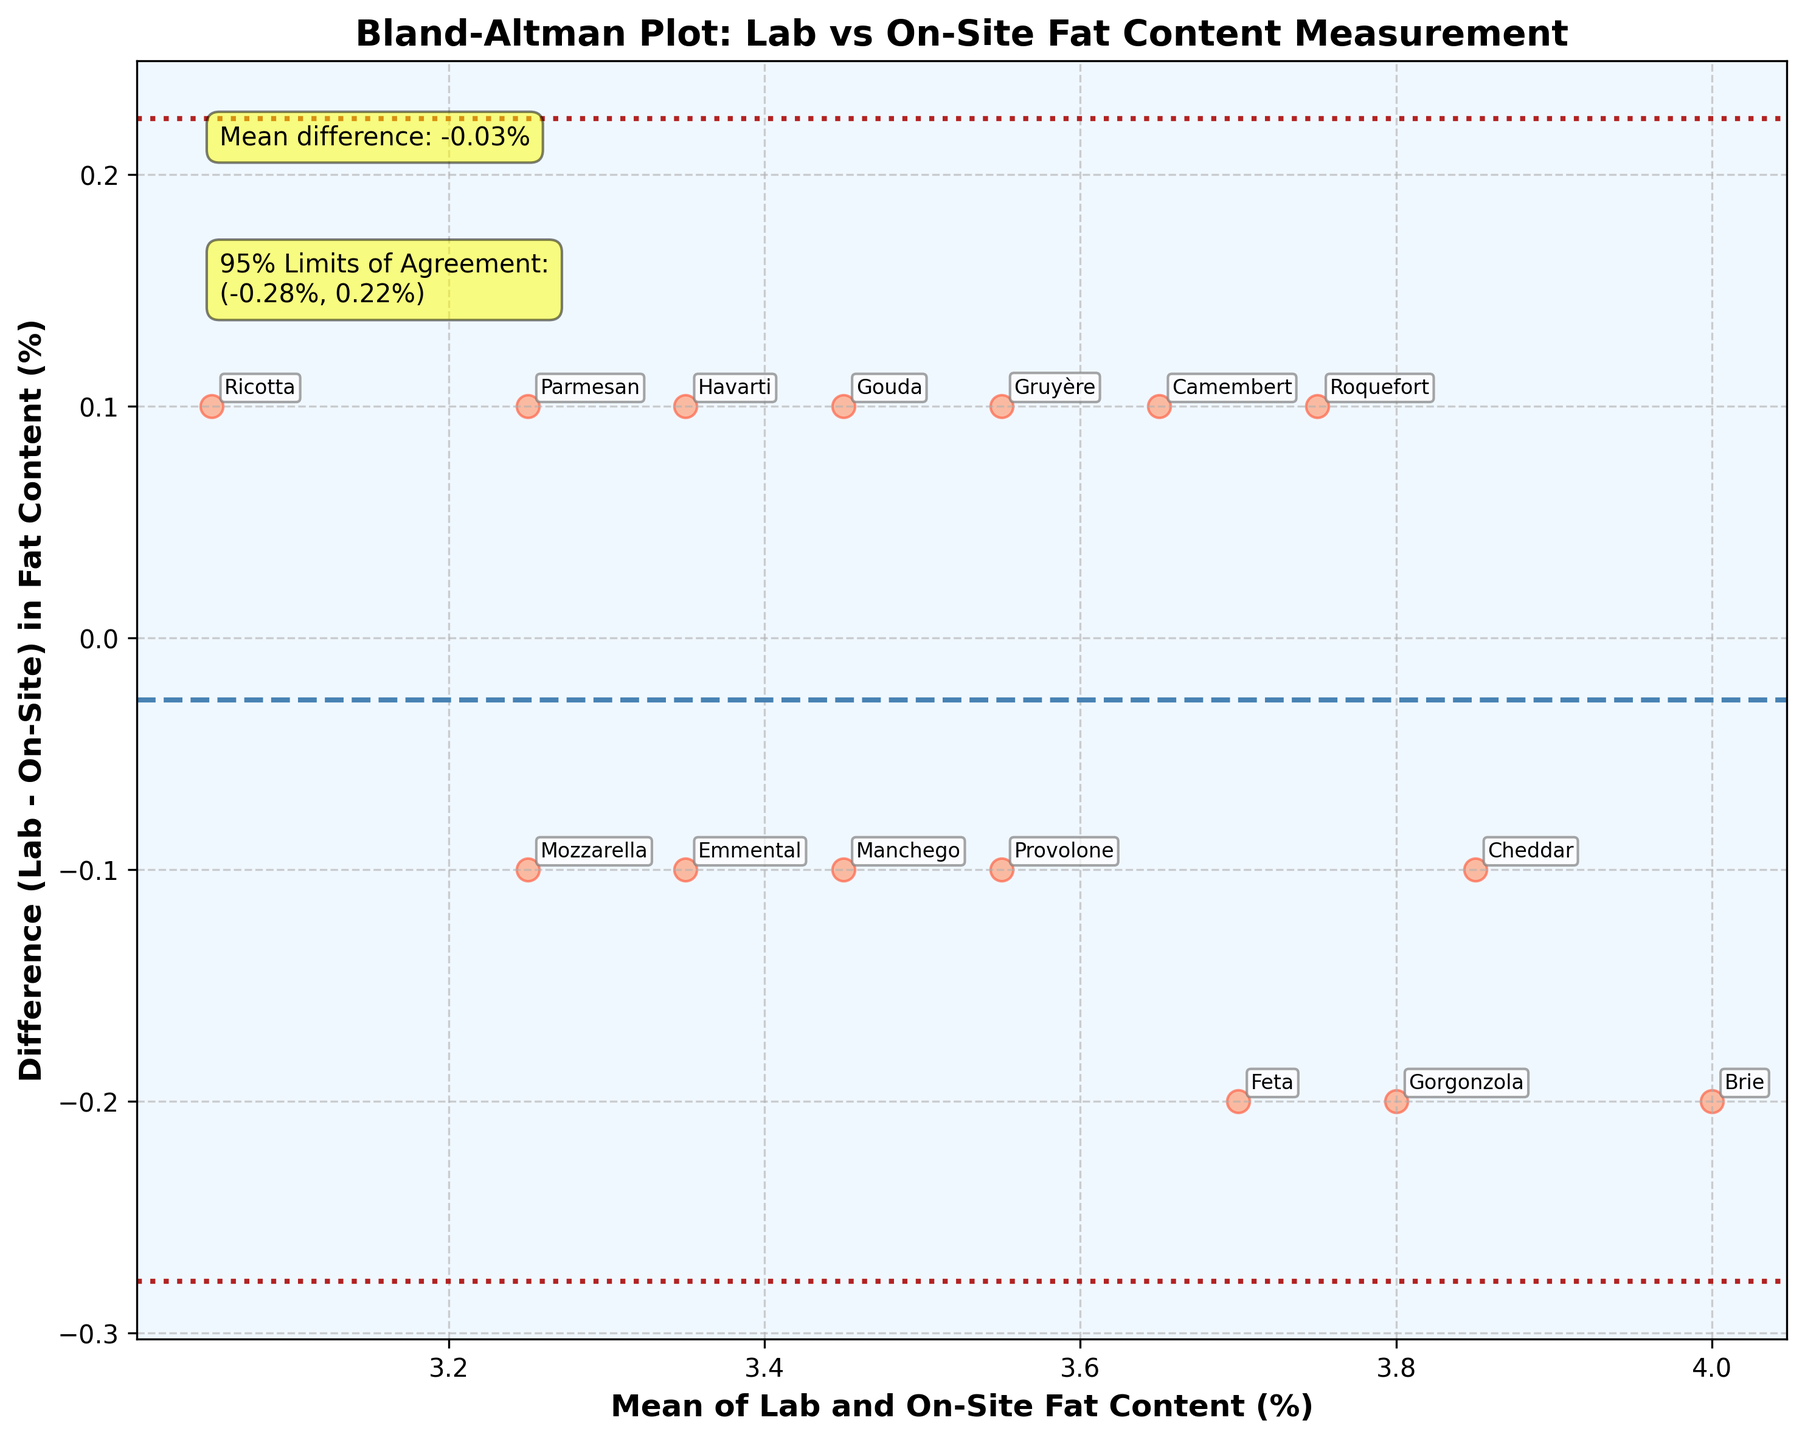How many data points are plotted in the Bland–Altman plot? Count the number of distinct cheese labels shown in the annotations; each label represents one data point. There are 15 cheese types, so there are 15 data points.
Answer: 15 What is the mean difference between the lab and on-site fat content measurements? Look for the information annotated on the plot. The mean difference is provided with a text box that states "Mean difference: 0.00%".
Answer: 0.00% What are the 95% limits of agreement for the fat content measurements? Look for the information annotated on the plot. The limits of agreement are provided with text that states "95% Limits of Agreement: (-0.22%, 0.22%)".
Answer: (-0.22%, 0.22%) Which cheese has the highest mean fat content between lab and on-site measurements? Identify the cheese closest to the highest value on the x-axis, which represents the mean of the lab and on-site fat content. Brie has the highest mean fat content because it is at the far right end of the x-axis with a value of 4.0%.
Answer: Brie Which cheese has the largest discrepancy between lab and on-site fat content measurements? Find the cheese label furthest away from the zero line on the y-axis, which represents the greatest difference. Brie has the largest discrepancy with a difference of -0.2%.
Answer: Brie For which cheese does the lab measurement exceed the on-site measurement the most? Look for the cheese labels that are above the zero line on the y-axis, which indicates a positive difference (lab measurement is higher). The highest point above the zero line belongs to Camembert with a difference of 0.1%.
Answer: Camembert What is the average mean fat content across all cheese types? Calculate the average of the x-axis values (mean fat content) by summing up all the means and dividing by the total number of cheeses (15). The means are 3.85, 3.45, 3.25, 4.00, 3.65, 3.25, 3.70, 3.45, 3.75, 3.55, 3.35, 3.55, 3.05, 3.80, 3.35 summing to 52.7. Thus, 52.7 / 15 = 3.51%.
Answer: 3.51% Which three cheese types have the smallest differences between lab and on-site fat content measurements? Identify the cheese labels closest to the zero line on the y-axis, indicating the smallest differences. Cheddar, Gouda, and Gruyère have the smallest differences (Cheddar and Gouda both at -0.1%, Gruyère at -0.1%).
Answer: Cheddar, Gouda, Gruyère 